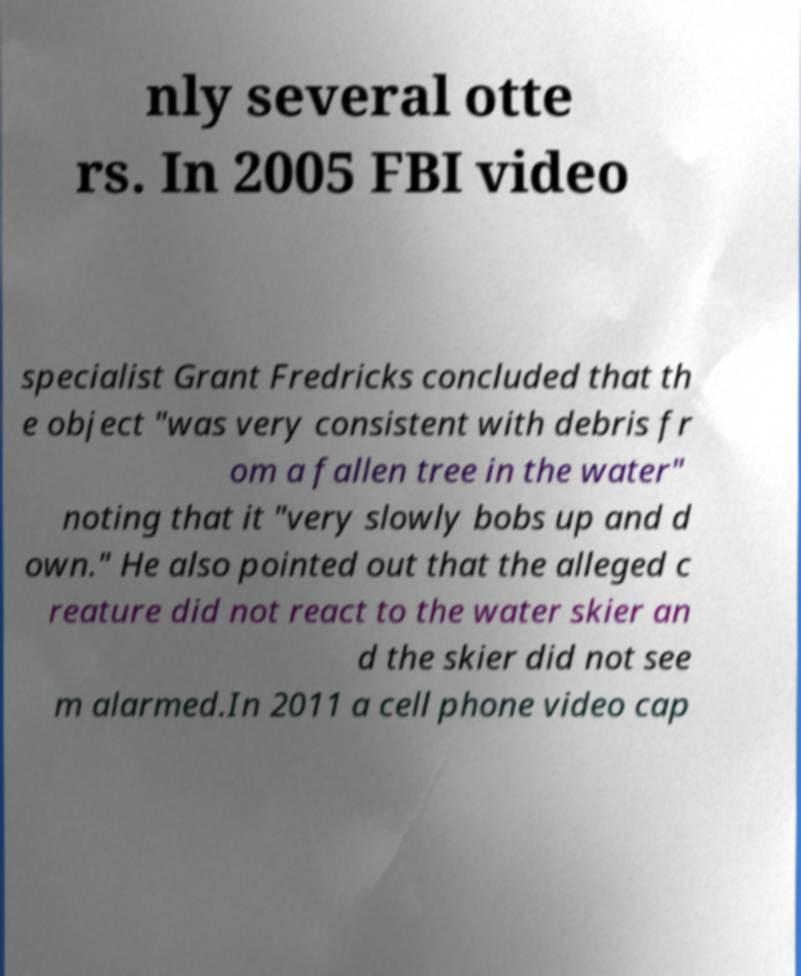I need the written content from this picture converted into text. Can you do that? nly several otte rs. In 2005 FBI video specialist Grant Fredricks concluded that th e object "was very consistent with debris fr om a fallen tree in the water" noting that it "very slowly bobs up and d own." He also pointed out that the alleged c reature did not react to the water skier an d the skier did not see m alarmed.In 2011 a cell phone video cap 